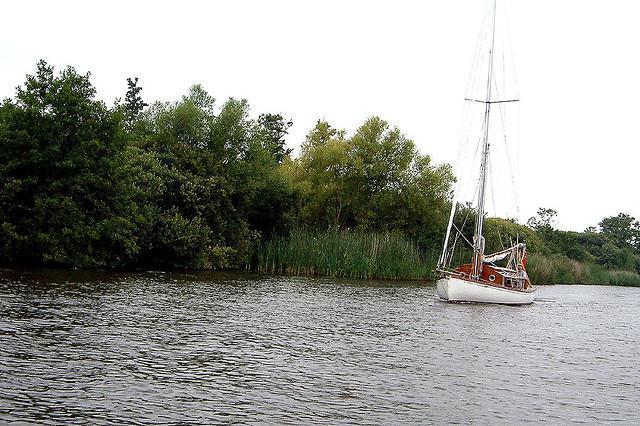How many boats are on the water?
Give a very brief answer. 1. 